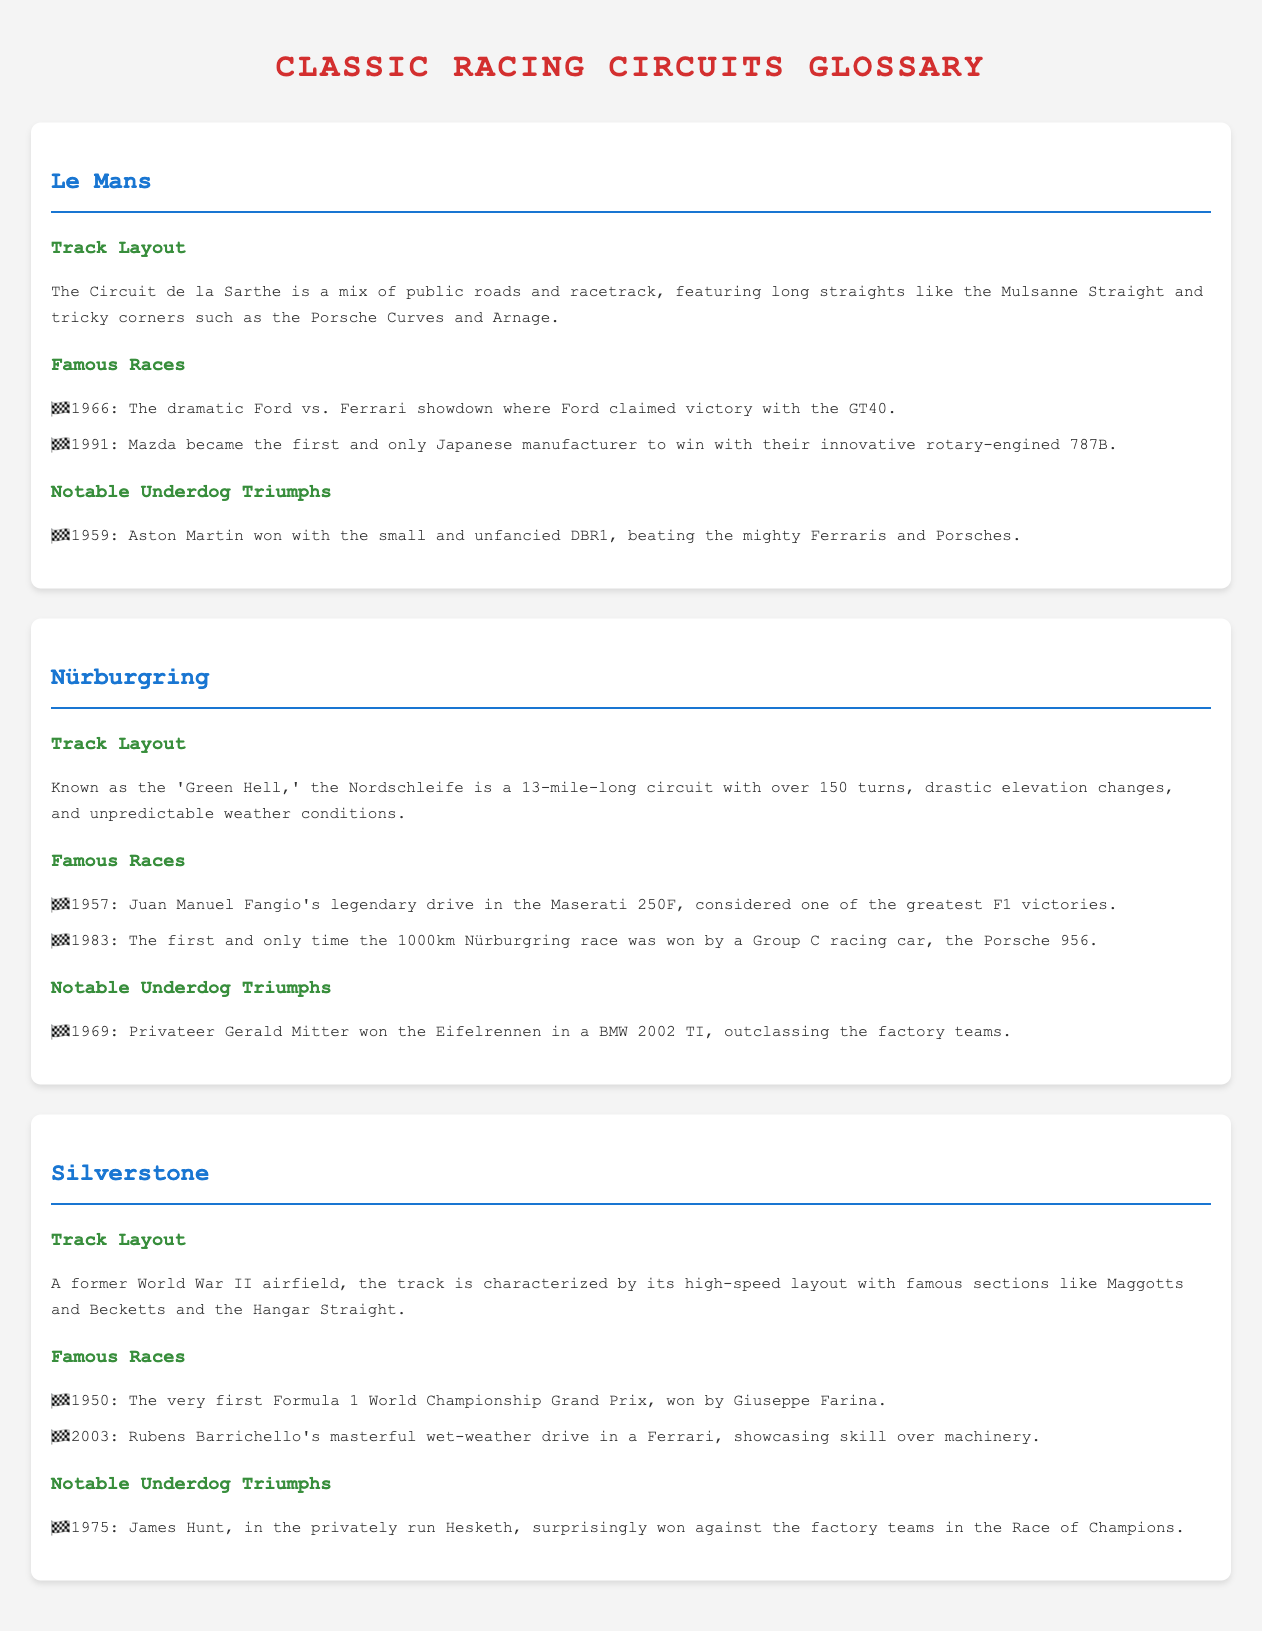What is the layout type of the Circuit de la Sarthe? The Circuit de la Sarthe features a mix of public roads and racetrack.
Answer: mix of public roads and racetrack In what year did Mazda win at Le Mans? Mazda became the first Japanese manufacturer to win at Le Mans in 1991.
Answer: 1991 Who won the 1975 Race of Champions? James Hunt won the 1975 Race of Champions in a privately run Hesketh.
Answer: James Hunt What notable underdog triumph occurred at the Nürburgring in 1969? Privateer Gerald Mitter won the Eifelrennen in a BMW 2002 TI.
Answer: Gerald Mitter What is the nickname of the Nordschleife track? The Nordschleife is known as the 'Green Hell.'
Answer: Green Hell Which famous race was won by Ford in 1966? The dramatic Ford vs. Ferrari showdown in 1966 was won by Ford with the GT40.
Answer: Ford vs. Ferrari showdown What year was the first Formula 1 World Championship Grand Prix held at Silverstone? The first Formula 1 World Championship Grand Prix was held in 1950.
Answer: 1950 Which racing car won the 1983 1000km Nürburgring race? The Porsche 956 won the 1983 1000km Nürburgring race.
Answer: Porsche 956 